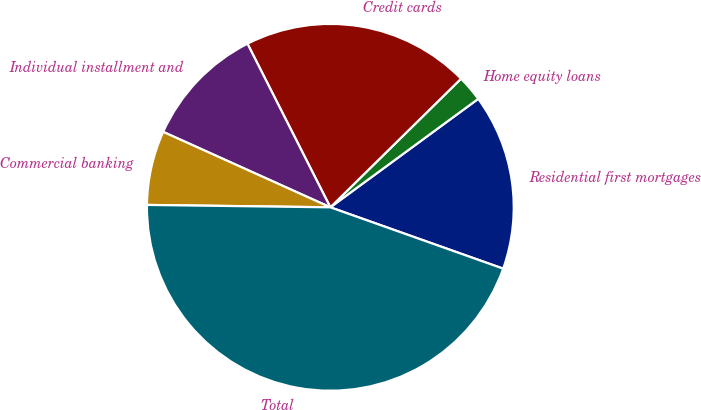Convert chart to OTSL. <chart><loc_0><loc_0><loc_500><loc_500><pie_chart><fcel>Residential first mortgages<fcel>Home equity loans<fcel>Credit cards<fcel>Individual installment and<fcel>Commercial banking<fcel>Total<nl><fcel>15.5%<fcel>2.3%<fcel>20.09%<fcel>10.79%<fcel>6.54%<fcel>44.78%<nl></chart> 